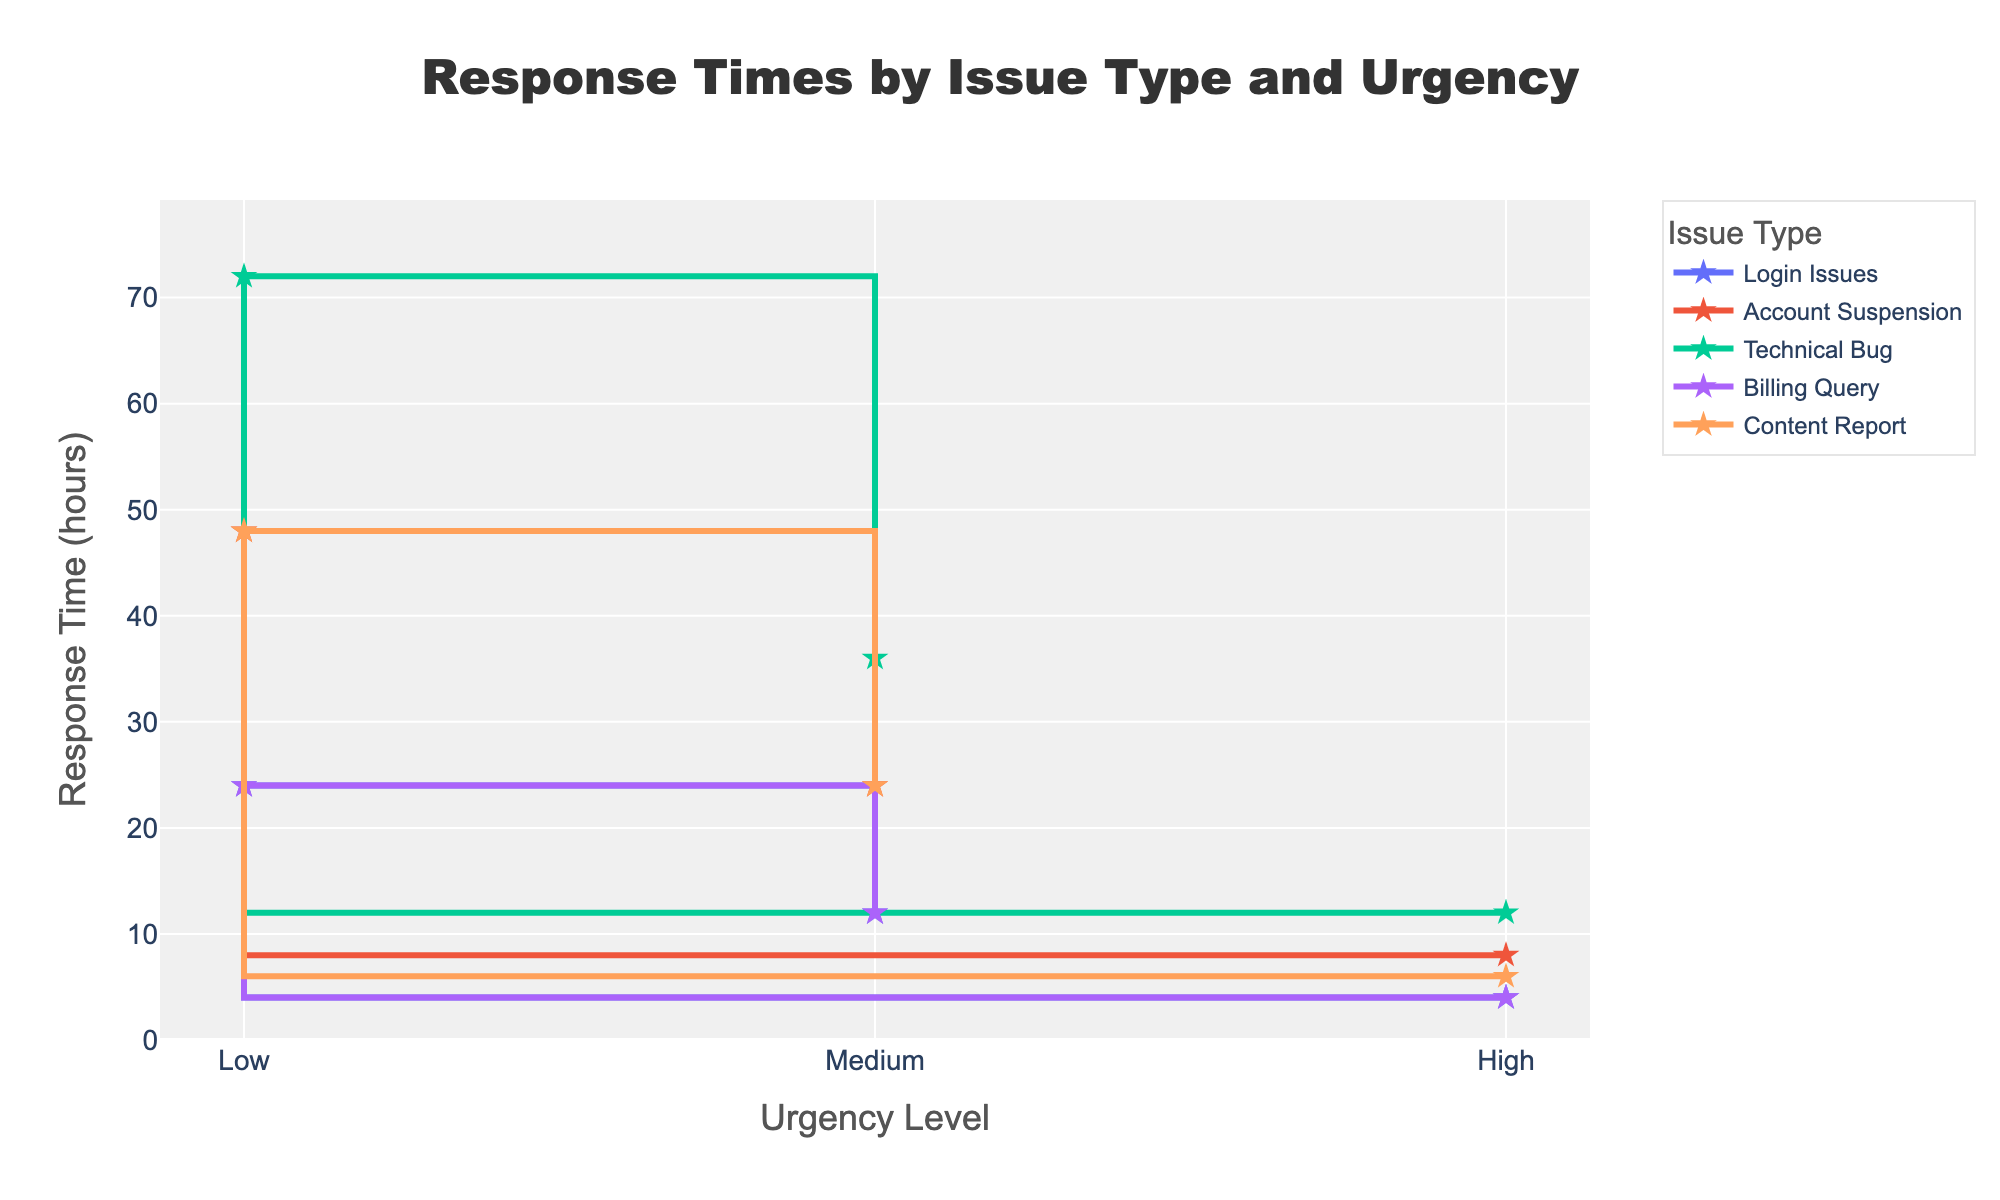What's the title of the figure? The title is clearly displayed at the top center of the plot.
Answer: Response Times by Issue Type and Urgency What is the response time for 'Account Suspension' with 'Medium' urgency? Find the line labeled 'Account Suspension' and locate the point corresponding to 'Medium' urgency to identify the response time.
Answer: 24 hours Which issue type has the highest response time for 'High' urgency level? Look at the end points of all lines at the 'High' urgency level. The highest value among them will point to the issue type.
Answer: Technical Bug How much longer is the response time for 'Technical Bug' with 'Medium' urgency compared to 'Login Issues' with 'Medium' urgency? Find the response times for 'Technical Bug' and 'Login Issues' at 'Medium' urgency. Subtract the value for 'Login Issues' from 'Technical Bug'.
Answer: 24 hours What is the average response time for 'Content Report' across all urgency levels? Add up the response times for 'Content Report' at Low (48 hours), Medium (24 hours), and High (6 hours) urgencies, and divide by the number of urgencies (3).
Answer: 26 hours Which issue type shows the steepest decline in response time as the urgency level goes from 'Low' to 'High'? Compare the slopes of each line representing different issue types. The line with the steepest downward slope shows the largest change.
Answer: Technical Bug What do the different colors of markers represent? The colors of markers are consistent with the urgency levels shown in the legend, indicating 'Low,' 'Medium,' and 'High' urgencies.
Answer: Urgency levels How many issue types have a response time of less than 10 hours for 'High' urgency? Check the data points at 'High' urgency level and count how many of them have response times below 10 hours. Four issue types meet this criterion.
Answer: Four (Login Issues, Account Suspension, Billing Query, Content Report) Which issue type has the same response time for 'Low' and 'Medium' urgency levels? Look for a line that remains horizontal between 'Low' and 'Medium' urgencies, indicating no change in response time.
Answer: Billing Query What is the total response time for 'Login Issues' across all urgency levels? Sum the response times for 'Login Issues' at Low (24), Medium (12), and High (4) urgencies. The total is 24 +12 + 4 = 40 hours.
Answer: 40 hours 